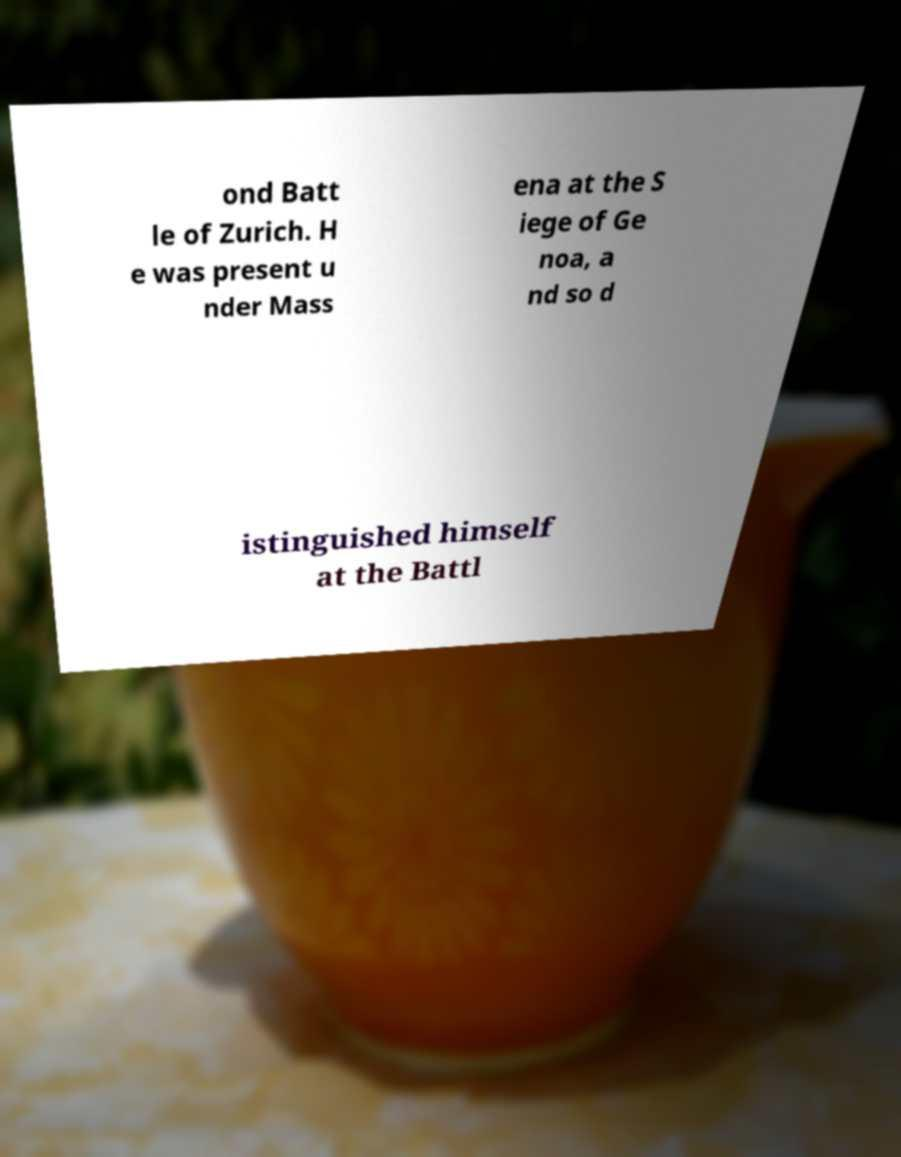Could you assist in decoding the text presented in this image and type it out clearly? ond Batt le of Zurich. H e was present u nder Mass ena at the S iege of Ge noa, a nd so d istinguished himself at the Battl 